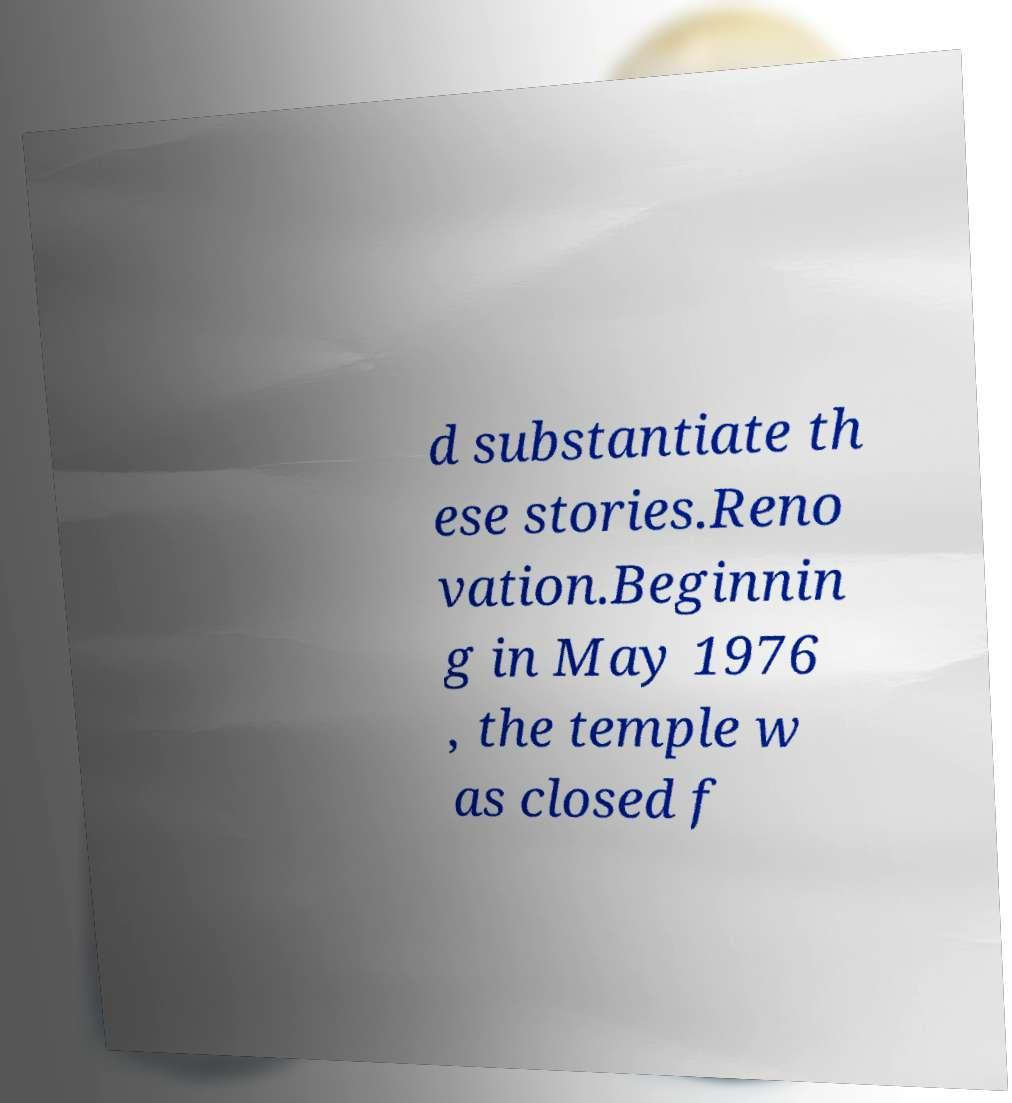I need the written content from this picture converted into text. Can you do that? d substantiate th ese stories.Reno vation.Beginnin g in May 1976 , the temple w as closed f 